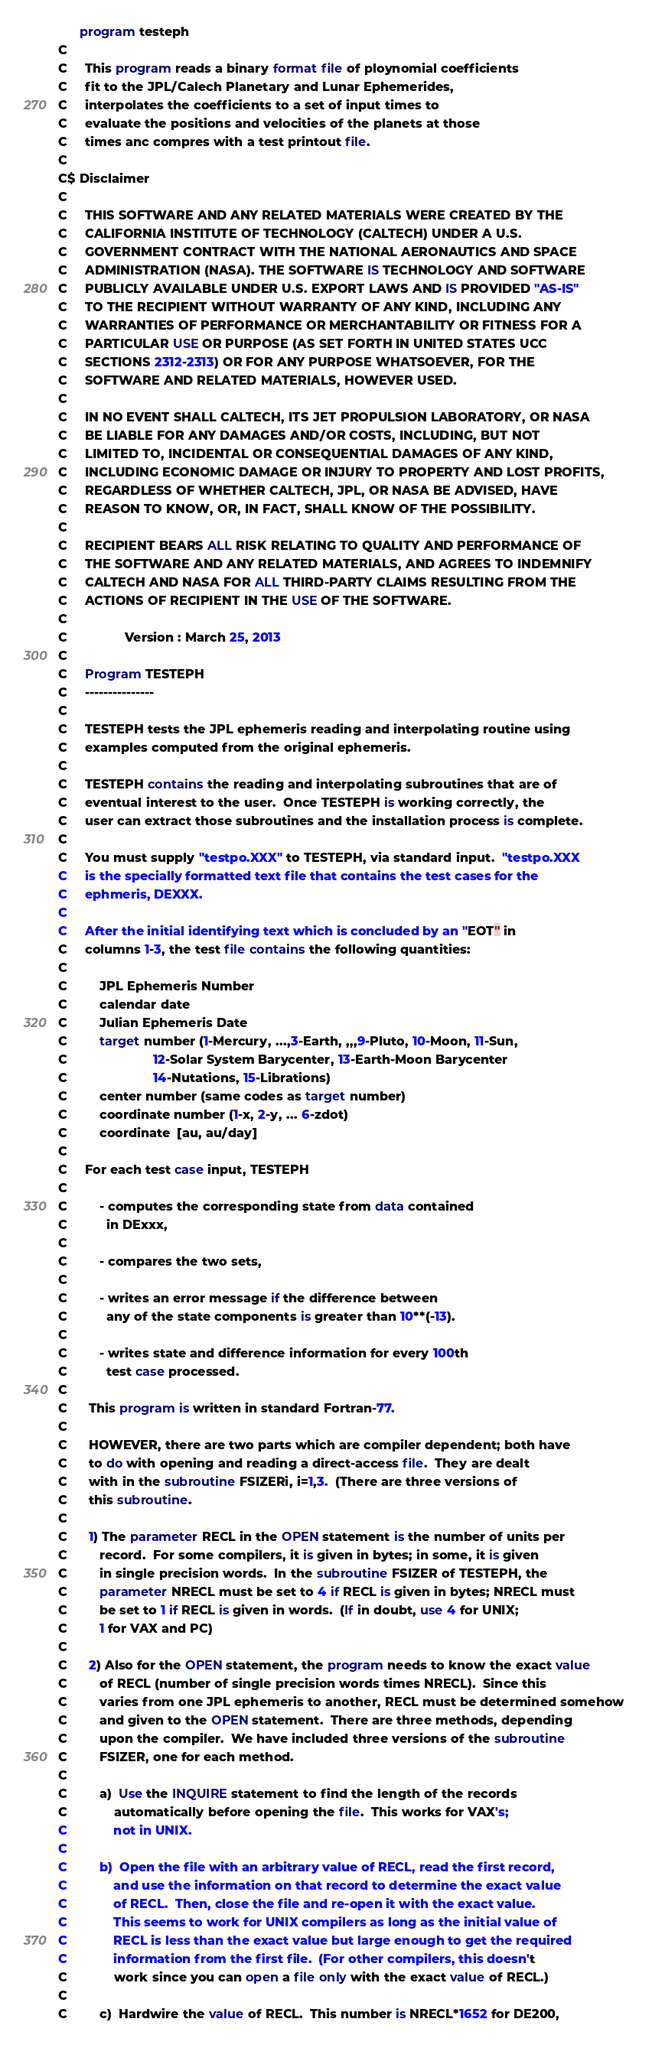Convert code to text. <code><loc_0><loc_0><loc_500><loc_500><_FORTRAN_>      program testeph
C
C     This program reads a binary format file of ploynomial coefficients
C     fit to the JPL/Calech Planetary and Lunar Ephemerides,
C     interpolates the coefficients to a set of input times to
C     evaluate the positions and velocities of the planets at those
C     times anc compres with a test printout file.
C
C$ Disclaimer
C
C     THIS SOFTWARE AND ANY RELATED MATERIALS WERE CREATED BY THE
C     CALIFORNIA INSTITUTE OF TECHNOLOGY (CALTECH) UNDER A U.S.
C     GOVERNMENT CONTRACT WITH THE NATIONAL AERONAUTICS AND SPACE
C     ADMINISTRATION (NASA). THE SOFTWARE IS TECHNOLOGY AND SOFTWARE
C     PUBLICLY AVAILABLE UNDER U.S. EXPORT LAWS AND IS PROVIDED "AS-IS"
C     TO THE RECIPIENT WITHOUT WARRANTY OF ANY KIND, INCLUDING ANY
C     WARRANTIES OF PERFORMANCE OR MERCHANTABILITY OR FITNESS FOR A
C     PARTICULAR USE OR PURPOSE (AS SET FORTH IN UNITED STATES UCC
C     SECTIONS 2312-2313) OR FOR ANY PURPOSE WHATSOEVER, FOR THE
C     SOFTWARE AND RELATED MATERIALS, HOWEVER USED.
C
C     IN NO EVENT SHALL CALTECH, ITS JET PROPULSION LABORATORY, OR NASA
C     BE LIABLE FOR ANY DAMAGES AND/OR COSTS, INCLUDING, BUT NOT
C     LIMITED TO, INCIDENTAL OR CONSEQUENTIAL DAMAGES OF ANY KIND,
C     INCLUDING ECONOMIC DAMAGE OR INJURY TO PROPERTY AND LOST PROFITS,
C     REGARDLESS OF WHETHER CALTECH, JPL, OR NASA BE ADVISED, HAVE
C     REASON TO KNOW, OR, IN FACT, SHALL KNOW OF THE POSSIBILITY.
C
C     RECIPIENT BEARS ALL RISK RELATING TO QUALITY AND PERFORMANCE OF
C     THE SOFTWARE AND ANY RELATED MATERIALS, AND AGREES TO INDEMNIFY
C     CALTECH AND NASA FOR ALL THIRD-PARTY CLAIMS RESULTING FROM THE
C     ACTIONS OF RECIPIENT IN THE USE OF THE SOFTWARE.
C
C                Version : March 25, 2013
C
C     Program TESTEPH
C     ---------------
C  
C     TESTEPH tests the JPL ephemeris reading and interpolating routine using
C     examples computed from the original ephemeris.
C
C     TESTEPH contains the reading and interpolating subroutines that are of 
C     eventual interest to the user.  Once TESTEPH is working correctly, the 
C     user can extract those subroutines and the installation process is complete.
C
C     You must supply "testpo.XXX" to TESTEPH, via standard input.  "testpo.XXX
C     is the specially formatted text file that contains the test cases for the 
C     ephmeris, DEXXX.
C
C     After the initial identifying text which is concluded by an "EOT" in
C     columns 1-3, the test file contains the following quantities:
C
C         JPL Ephemeris Number
C         calendar date
C         Julian Ephemeris Date
C         target number (1-Mercury, ...,3-Earth, ,,,9-Pluto, 10-Moon, 11-Sun,
C                        12-Solar System Barycenter, 13-Earth-Moon Barycenter
C                        14-Nutations, 15-Librations)
C         center number (same codes as target number)
C         coordinate number (1-x, 2-y, ... 6-zdot) 
C         coordinate  [au, au/day]
C
C     For each test case input, TESTEPH
C
C         - computes the corresponding state from data contained 
C           in DExxx,
C
C         - compares the two sets,
C
C         - writes an error message if the difference between
C           any of the state components is greater than 10**(-13).
C
C         - writes state and difference information for every 100th
C           test case processed.
C
C      This program is written in standard Fortran-77.  
C
C      HOWEVER, there are two parts which are compiler dependent; both have
C      to do with opening and reading a direct-access file.  They are dealt
C      with in the subroutine FSIZERi, i=1,3.  (There are three versions of 
C      this subroutine.
C
C      1) The parameter RECL in the OPEN statement is the number of units per 
C         record.  For some compilers, it is given in bytes; in some, it is given
C         in single precision words.  In the subroutine FSIZER of TESTEPH, the
C         parameter NRECL must be set to 4 if RECL is given in bytes; NRECL must 
C         be set to 1 if RECL is given in words.  (If in doubt, use 4 for UNIX;
C         1 for VAX and PC)
C
C      2) Also for the OPEN statement, the program needs to know the exact value
C         of RECL (number of single precision words times NRECL).  Since this 
C         varies from one JPL ephemeris to another, RECL must be determined somehow 
C         and given to the OPEN statement.  There are three methods, depending 
C         upon the compiler.  We have included three versions of the subroutine 
C         FSIZER, one for each method.
C
C         a)  Use the INQUIRE statement to find the length of the records 
C             automatically before opening the file.  This works for VAX's; 
C             not in UNIX.
C
C         b)  Open the file with an arbitrary value of RECL, read the first record,
C             and use the information on that record to determine the exact value
C             of RECL.  Then, close the file and re-open it with the exact value.
C             This seems to work for UNIX compilers as long as the initial value of
C             RECL is less than the exact value but large enough to get the required 
C             information from the first file.  (For other compilers, this doesn't
C             work since you can open a file only with the exact value of RECL.)
C
C         c)  Hardwire the value of RECL.  This number is NRECL*1652 for DE200, </code> 